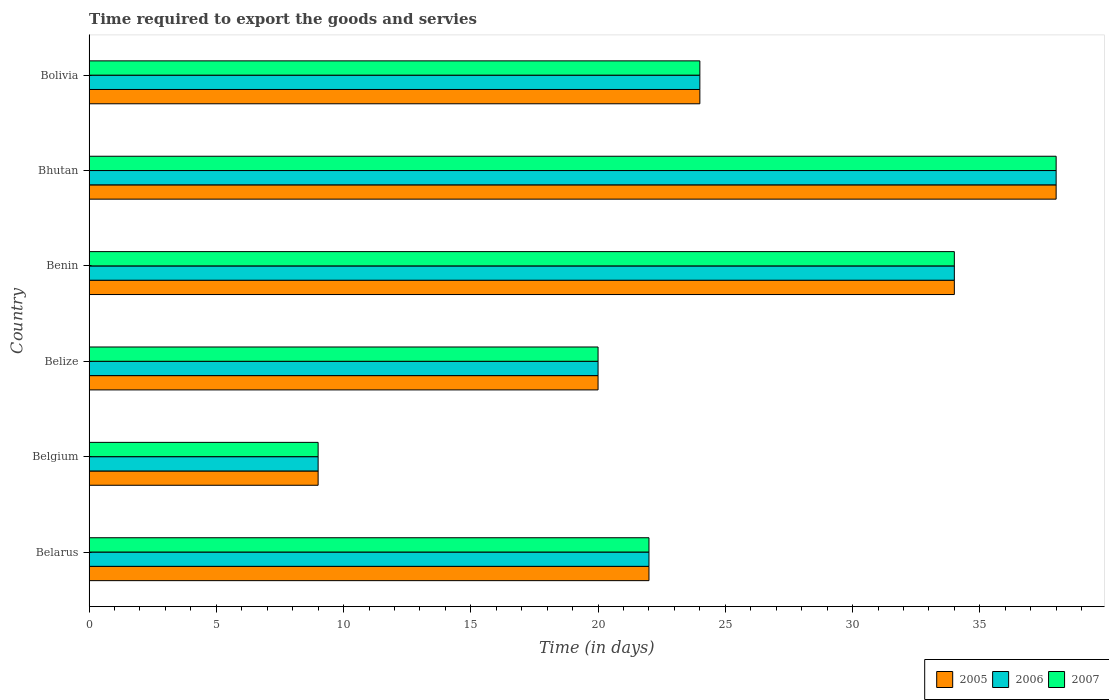Are the number of bars on each tick of the Y-axis equal?
Give a very brief answer. Yes. How many bars are there on the 4th tick from the top?
Ensure brevity in your answer.  3. What is the label of the 3rd group of bars from the top?
Your response must be concise. Benin. In how many cases, is the number of bars for a given country not equal to the number of legend labels?
Offer a terse response. 0. What is the number of days required to export the goods and services in 2006 in Belize?
Give a very brief answer. 20. Across all countries, what is the maximum number of days required to export the goods and services in 2005?
Keep it short and to the point. 38. In which country was the number of days required to export the goods and services in 2006 maximum?
Make the answer very short. Bhutan. What is the total number of days required to export the goods and services in 2007 in the graph?
Give a very brief answer. 147. What is the difference between the number of days required to export the goods and services in 2006 in Bolivia and the number of days required to export the goods and services in 2007 in Belarus?
Your answer should be very brief. 2. What is the difference between the number of days required to export the goods and services in 2005 and number of days required to export the goods and services in 2006 in Bolivia?
Make the answer very short. 0. In how many countries, is the number of days required to export the goods and services in 2005 greater than 10 days?
Keep it short and to the point. 5. What is the ratio of the number of days required to export the goods and services in 2007 in Belgium to that in Bolivia?
Offer a terse response. 0.38. Is the number of days required to export the goods and services in 2005 in Belarus less than that in Belize?
Offer a terse response. No. What is the difference between the highest and the second highest number of days required to export the goods and services in 2006?
Offer a terse response. 4. What is the difference between the highest and the lowest number of days required to export the goods and services in 2007?
Provide a short and direct response. 29. In how many countries, is the number of days required to export the goods and services in 2007 greater than the average number of days required to export the goods and services in 2007 taken over all countries?
Provide a succinct answer. 2. Is the sum of the number of days required to export the goods and services in 2005 in Belarus and Bolivia greater than the maximum number of days required to export the goods and services in 2007 across all countries?
Make the answer very short. Yes. What does the 2nd bar from the bottom in Bolivia represents?
Your answer should be very brief. 2006. Is it the case that in every country, the sum of the number of days required to export the goods and services in 2005 and number of days required to export the goods and services in 2006 is greater than the number of days required to export the goods and services in 2007?
Provide a succinct answer. Yes. How many countries are there in the graph?
Your answer should be compact. 6. Are the values on the major ticks of X-axis written in scientific E-notation?
Give a very brief answer. No. Does the graph contain any zero values?
Offer a very short reply. No. Does the graph contain grids?
Keep it short and to the point. No. Where does the legend appear in the graph?
Make the answer very short. Bottom right. How many legend labels are there?
Ensure brevity in your answer.  3. What is the title of the graph?
Your answer should be very brief. Time required to export the goods and servies. Does "1988" appear as one of the legend labels in the graph?
Give a very brief answer. No. What is the label or title of the X-axis?
Offer a very short reply. Time (in days). What is the Time (in days) of 2005 in Belarus?
Make the answer very short. 22. What is the Time (in days) of 2007 in Belarus?
Offer a terse response. 22. What is the Time (in days) of 2005 in Belgium?
Your answer should be very brief. 9. What is the Time (in days) in 2007 in Belgium?
Your answer should be compact. 9. What is the Time (in days) of 2005 in Belize?
Provide a succinct answer. 20. What is the Time (in days) in 2007 in Belize?
Ensure brevity in your answer.  20. What is the Time (in days) in 2005 in Benin?
Your answer should be very brief. 34. What is the Time (in days) in 2006 in Benin?
Give a very brief answer. 34. What is the Time (in days) in 2007 in Benin?
Provide a succinct answer. 34. What is the Time (in days) in 2005 in Bhutan?
Your answer should be compact. 38. What is the Time (in days) of 2006 in Bhutan?
Give a very brief answer. 38. What is the Time (in days) in 2007 in Bhutan?
Your answer should be very brief. 38. What is the Time (in days) in 2007 in Bolivia?
Your answer should be very brief. 24. Across all countries, what is the maximum Time (in days) of 2006?
Provide a short and direct response. 38. Across all countries, what is the maximum Time (in days) in 2007?
Make the answer very short. 38. Across all countries, what is the minimum Time (in days) in 2006?
Offer a very short reply. 9. Across all countries, what is the minimum Time (in days) in 2007?
Give a very brief answer. 9. What is the total Time (in days) of 2005 in the graph?
Keep it short and to the point. 147. What is the total Time (in days) of 2006 in the graph?
Keep it short and to the point. 147. What is the total Time (in days) of 2007 in the graph?
Your response must be concise. 147. What is the difference between the Time (in days) in 2005 in Belarus and that in Belgium?
Your response must be concise. 13. What is the difference between the Time (in days) of 2006 in Belarus and that in Belgium?
Make the answer very short. 13. What is the difference between the Time (in days) of 2007 in Belarus and that in Belgium?
Ensure brevity in your answer.  13. What is the difference between the Time (in days) of 2005 in Belarus and that in Belize?
Offer a very short reply. 2. What is the difference between the Time (in days) in 2006 in Belarus and that in Belize?
Your response must be concise. 2. What is the difference between the Time (in days) in 2006 in Belarus and that in Benin?
Your response must be concise. -12. What is the difference between the Time (in days) of 2007 in Belarus and that in Benin?
Your response must be concise. -12. What is the difference between the Time (in days) in 2005 in Belarus and that in Bhutan?
Your answer should be compact. -16. What is the difference between the Time (in days) of 2007 in Belarus and that in Bhutan?
Provide a succinct answer. -16. What is the difference between the Time (in days) in 2005 in Belarus and that in Bolivia?
Make the answer very short. -2. What is the difference between the Time (in days) in 2007 in Belarus and that in Bolivia?
Keep it short and to the point. -2. What is the difference between the Time (in days) in 2005 in Belgium and that in Belize?
Provide a short and direct response. -11. What is the difference between the Time (in days) in 2006 in Belgium and that in Benin?
Offer a terse response. -25. What is the difference between the Time (in days) of 2007 in Belgium and that in Benin?
Ensure brevity in your answer.  -25. What is the difference between the Time (in days) in 2005 in Belgium and that in Bhutan?
Your answer should be compact. -29. What is the difference between the Time (in days) in 2007 in Belgium and that in Bhutan?
Ensure brevity in your answer.  -29. What is the difference between the Time (in days) of 2006 in Belgium and that in Bolivia?
Keep it short and to the point. -15. What is the difference between the Time (in days) in 2006 in Belize and that in Benin?
Ensure brevity in your answer.  -14. What is the difference between the Time (in days) in 2005 in Belize and that in Bhutan?
Your answer should be very brief. -18. What is the difference between the Time (in days) in 2005 in Belize and that in Bolivia?
Offer a terse response. -4. What is the difference between the Time (in days) in 2005 in Bhutan and that in Bolivia?
Give a very brief answer. 14. What is the difference between the Time (in days) in 2006 in Bhutan and that in Bolivia?
Your answer should be compact. 14. What is the difference between the Time (in days) of 2005 in Belarus and the Time (in days) of 2006 in Belgium?
Provide a short and direct response. 13. What is the difference between the Time (in days) of 2005 in Belarus and the Time (in days) of 2007 in Belize?
Give a very brief answer. 2. What is the difference between the Time (in days) in 2006 in Belarus and the Time (in days) in 2007 in Belize?
Your answer should be compact. 2. What is the difference between the Time (in days) in 2005 in Belarus and the Time (in days) in 2007 in Benin?
Your answer should be very brief. -12. What is the difference between the Time (in days) of 2006 in Belarus and the Time (in days) of 2007 in Benin?
Provide a short and direct response. -12. What is the difference between the Time (in days) in 2005 in Belarus and the Time (in days) in 2006 in Bhutan?
Your answer should be very brief. -16. What is the difference between the Time (in days) in 2005 in Belarus and the Time (in days) in 2007 in Bhutan?
Ensure brevity in your answer.  -16. What is the difference between the Time (in days) of 2006 in Belarus and the Time (in days) of 2007 in Bhutan?
Ensure brevity in your answer.  -16. What is the difference between the Time (in days) of 2005 in Belarus and the Time (in days) of 2006 in Bolivia?
Give a very brief answer. -2. What is the difference between the Time (in days) in 2005 in Belarus and the Time (in days) in 2007 in Bolivia?
Your response must be concise. -2. What is the difference between the Time (in days) of 2006 in Belarus and the Time (in days) of 2007 in Bolivia?
Ensure brevity in your answer.  -2. What is the difference between the Time (in days) in 2005 in Belgium and the Time (in days) in 2006 in Belize?
Offer a terse response. -11. What is the difference between the Time (in days) in 2005 in Belgium and the Time (in days) in 2007 in Belize?
Your response must be concise. -11. What is the difference between the Time (in days) in 2005 in Belgium and the Time (in days) in 2006 in Benin?
Provide a short and direct response. -25. What is the difference between the Time (in days) of 2005 in Belgium and the Time (in days) of 2007 in Bhutan?
Keep it short and to the point. -29. What is the difference between the Time (in days) of 2005 in Belgium and the Time (in days) of 2006 in Bolivia?
Keep it short and to the point. -15. What is the difference between the Time (in days) in 2006 in Belgium and the Time (in days) in 2007 in Bolivia?
Offer a very short reply. -15. What is the difference between the Time (in days) in 2005 in Belize and the Time (in days) in 2006 in Benin?
Your response must be concise. -14. What is the difference between the Time (in days) of 2005 in Belize and the Time (in days) of 2007 in Benin?
Ensure brevity in your answer.  -14. What is the difference between the Time (in days) in 2005 in Belize and the Time (in days) in 2007 in Bhutan?
Give a very brief answer. -18. What is the difference between the Time (in days) of 2005 in Belize and the Time (in days) of 2006 in Bolivia?
Make the answer very short. -4. What is the difference between the Time (in days) in 2005 in Belize and the Time (in days) in 2007 in Bolivia?
Your answer should be very brief. -4. What is the difference between the Time (in days) of 2006 in Belize and the Time (in days) of 2007 in Bolivia?
Provide a succinct answer. -4. What is the difference between the Time (in days) of 2005 in Benin and the Time (in days) of 2006 in Bhutan?
Your answer should be compact. -4. What is the difference between the Time (in days) of 2005 in Benin and the Time (in days) of 2007 in Bhutan?
Keep it short and to the point. -4. What is the difference between the Time (in days) of 2006 in Benin and the Time (in days) of 2007 in Bhutan?
Give a very brief answer. -4. What is the difference between the Time (in days) in 2005 in Benin and the Time (in days) in 2006 in Bolivia?
Your response must be concise. 10. What is the difference between the Time (in days) of 2005 in Benin and the Time (in days) of 2007 in Bolivia?
Keep it short and to the point. 10. What is the difference between the Time (in days) of 2006 in Benin and the Time (in days) of 2007 in Bolivia?
Ensure brevity in your answer.  10. What is the average Time (in days) of 2005 per country?
Provide a succinct answer. 24.5. What is the average Time (in days) in 2007 per country?
Your answer should be compact. 24.5. What is the difference between the Time (in days) in 2005 and Time (in days) in 2006 in Belarus?
Offer a very short reply. 0. What is the difference between the Time (in days) in 2005 and Time (in days) in 2007 in Belarus?
Give a very brief answer. 0. What is the difference between the Time (in days) in 2005 and Time (in days) in 2006 in Belize?
Provide a short and direct response. 0. What is the difference between the Time (in days) of 2005 and Time (in days) of 2007 in Belize?
Offer a very short reply. 0. What is the difference between the Time (in days) in 2005 and Time (in days) in 2007 in Benin?
Your answer should be compact. 0. What is the difference between the Time (in days) in 2005 and Time (in days) in 2007 in Bhutan?
Ensure brevity in your answer.  0. What is the ratio of the Time (in days) in 2005 in Belarus to that in Belgium?
Offer a very short reply. 2.44. What is the ratio of the Time (in days) of 2006 in Belarus to that in Belgium?
Your response must be concise. 2.44. What is the ratio of the Time (in days) of 2007 in Belarus to that in Belgium?
Offer a very short reply. 2.44. What is the ratio of the Time (in days) in 2005 in Belarus to that in Belize?
Ensure brevity in your answer.  1.1. What is the ratio of the Time (in days) of 2005 in Belarus to that in Benin?
Offer a very short reply. 0.65. What is the ratio of the Time (in days) of 2006 in Belarus to that in Benin?
Provide a succinct answer. 0.65. What is the ratio of the Time (in days) in 2007 in Belarus to that in Benin?
Offer a terse response. 0.65. What is the ratio of the Time (in days) in 2005 in Belarus to that in Bhutan?
Keep it short and to the point. 0.58. What is the ratio of the Time (in days) in 2006 in Belarus to that in Bhutan?
Provide a short and direct response. 0.58. What is the ratio of the Time (in days) of 2007 in Belarus to that in Bhutan?
Offer a very short reply. 0.58. What is the ratio of the Time (in days) in 2007 in Belarus to that in Bolivia?
Your response must be concise. 0.92. What is the ratio of the Time (in days) of 2005 in Belgium to that in Belize?
Make the answer very short. 0.45. What is the ratio of the Time (in days) in 2006 in Belgium to that in Belize?
Your response must be concise. 0.45. What is the ratio of the Time (in days) of 2007 in Belgium to that in Belize?
Offer a terse response. 0.45. What is the ratio of the Time (in days) of 2005 in Belgium to that in Benin?
Offer a very short reply. 0.26. What is the ratio of the Time (in days) of 2006 in Belgium to that in Benin?
Give a very brief answer. 0.26. What is the ratio of the Time (in days) in 2007 in Belgium to that in Benin?
Your answer should be compact. 0.26. What is the ratio of the Time (in days) in 2005 in Belgium to that in Bhutan?
Offer a very short reply. 0.24. What is the ratio of the Time (in days) of 2006 in Belgium to that in Bhutan?
Your answer should be compact. 0.24. What is the ratio of the Time (in days) in 2007 in Belgium to that in Bhutan?
Make the answer very short. 0.24. What is the ratio of the Time (in days) in 2005 in Belize to that in Benin?
Keep it short and to the point. 0.59. What is the ratio of the Time (in days) in 2006 in Belize to that in Benin?
Your answer should be very brief. 0.59. What is the ratio of the Time (in days) of 2007 in Belize to that in Benin?
Your answer should be very brief. 0.59. What is the ratio of the Time (in days) in 2005 in Belize to that in Bhutan?
Provide a short and direct response. 0.53. What is the ratio of the Time (in days) of 2006 in Belize to that in Bhutan?
Ensure brevity in your answer.  0.53. What is the ratio of the Time (in days) in 2007 in Belize to that in Bhutan?
Offer a terse response. 0.53. What is the ratio of the Time (in days) in 2006 in Belize to that in Bolivia?
Make the answer very short. 0.83. What is the ratio of the Time (in days) of 2005 in Benin to that in Bhutan?
Your response must be concise. 0.89. What is the ratio of the Time (in days) in 2006 in Benin to that in Bhutan?
Keep it short and to the point. 0.89. What is the ratio of the Time (in days) of 2007 in Benin to that in Bhutan?
Your answer should be very brief. 0.89. What is the ratio of the Time (in days) of 2005 in Benin to that in Bolivia?
Your answer should be compact. 1.42. What is the ratio of the Time (in days) of 2006 in Benin to that in Bolivia?
Offer a very short reply. 1.42. What is the ratio of the Time (in days) of 2007 in Benin to that in Bolivia?
Give a very brief answer. 1.42. What is the ratio of the Time (in days) of 2005 in Bhutan to that in Bolivia?
Your answer should be very brief. 1.58. What is the ratio of the Time (in days) in 2006 in Bhutan to that in Bolivia?
Provide a succinct answer. 1.58. What is the ratio of the Time (in days) of 2007 in Bhutan to that in Bolivia?
Make the answer very short. 1.58. What is the difference between the highest and the second highest Time (in days) of 2005?
Provide a succinct answer. 4. What is the difference between the highest and the second highest Time (in days) in 2006?
Ensure brevity in your answer.  4. What is the difference between the highest and the second highest Time (in days) of 2007?
Your answer should be very brief. 4. What is the difference between the highest and the lowest Time (in days) of 2006?
Ensure brevity in your answer.  29. 